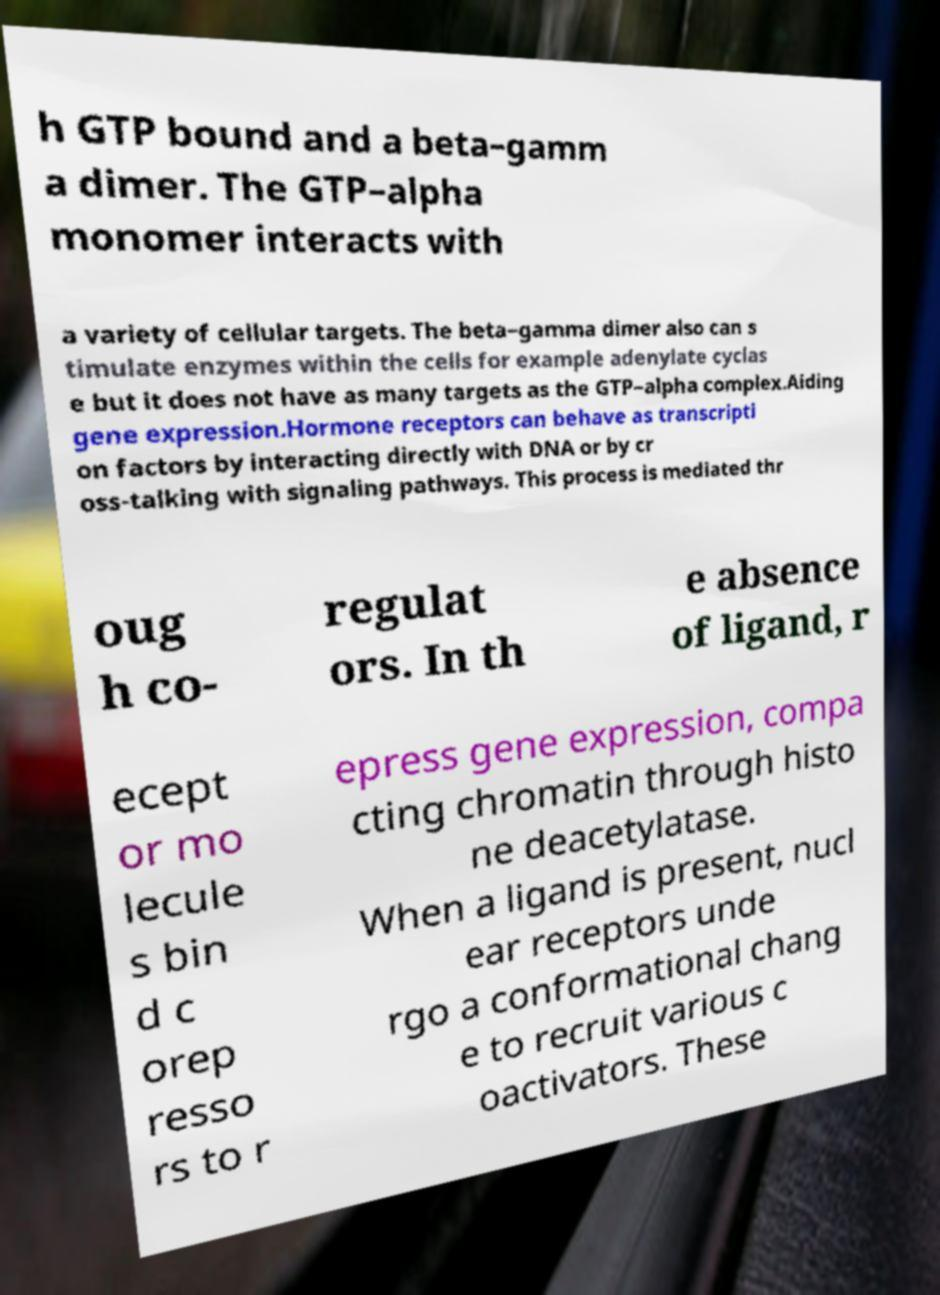Can you read and provide the text displayed in the image?This photo seems to have some interesting text. Can you extract and type it out for me? h GTP bound and a beta–gamm a dimer. The GTP–alpha monomer interacts with a variety of cellular targets. The beta–gamma dimer also can s timulate enzymes within the cells for example adenylate cyclas e but it does not have as many targets as the GTP–alpha complex.Aiding gene expression.Hormone receptors can behave as transcripti on factors by interacting directly with DNA or by cr oss-talking with signaling pathways. This process is mediated thr oug h co- regulat ors. In th e absence of ligand, r ecept or mo lecule s bin d c orep resso rs to r epress gene expression, compa cting chromatin through histo ne deacetylatase. When a ligand is present, nucl ear receptors unde rgo a conformational chang e to recruit various c oactivators. These 